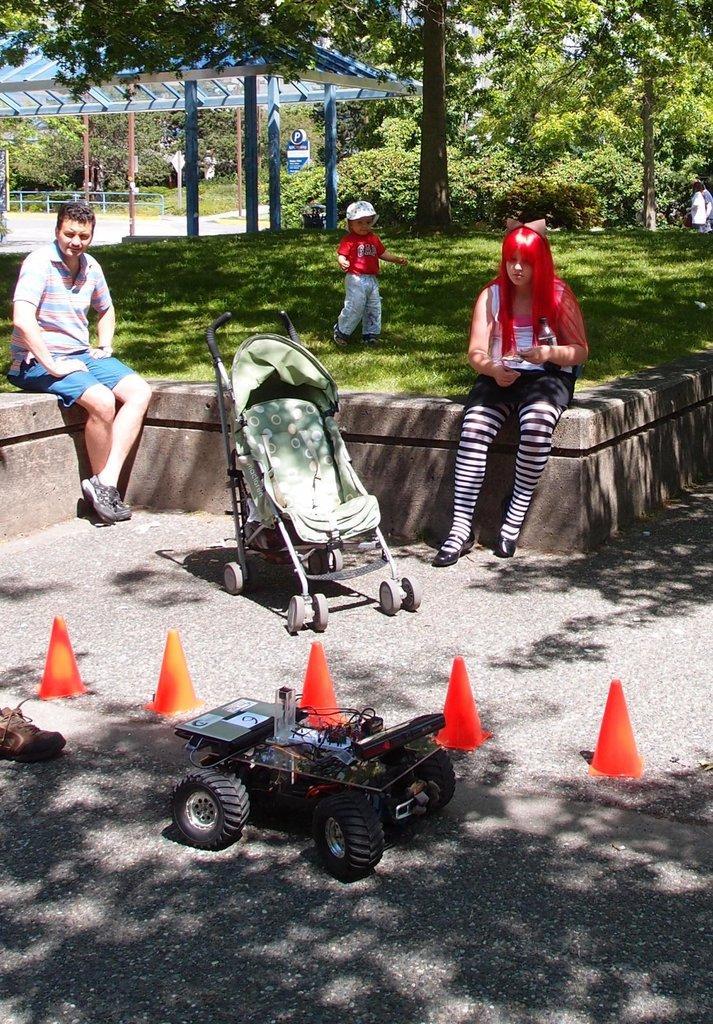Can you describe this image briefly? In the center of the image we can see a boy standing on the ground. Two persons are sitting on the floor, a baby carrier is placed on the ground. In the foreground we can see a toy, group of cones and a shoe is placed on the ground. In the background, we can see the poles, shed, barricade, group of trees and some people standing. 